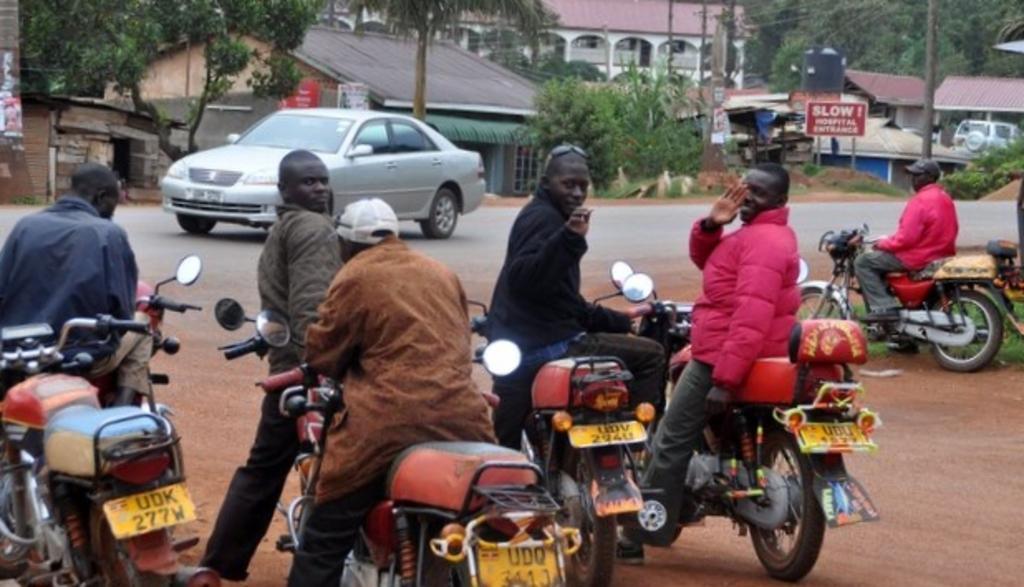Please provide a concise description of this image. In this picture there are many people sitting on a bikes. Some of them are wearing spectacles on their heads. In the background, there is a car on the road. We can observe some plants, trees and some houses here. 